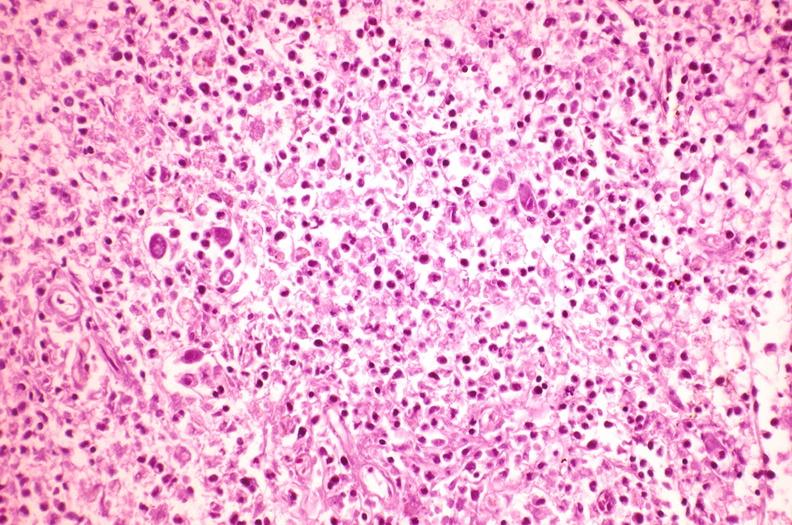does this image show spleen, cytomegalovirus?
Answer the question using a single word or phrase. Yes 